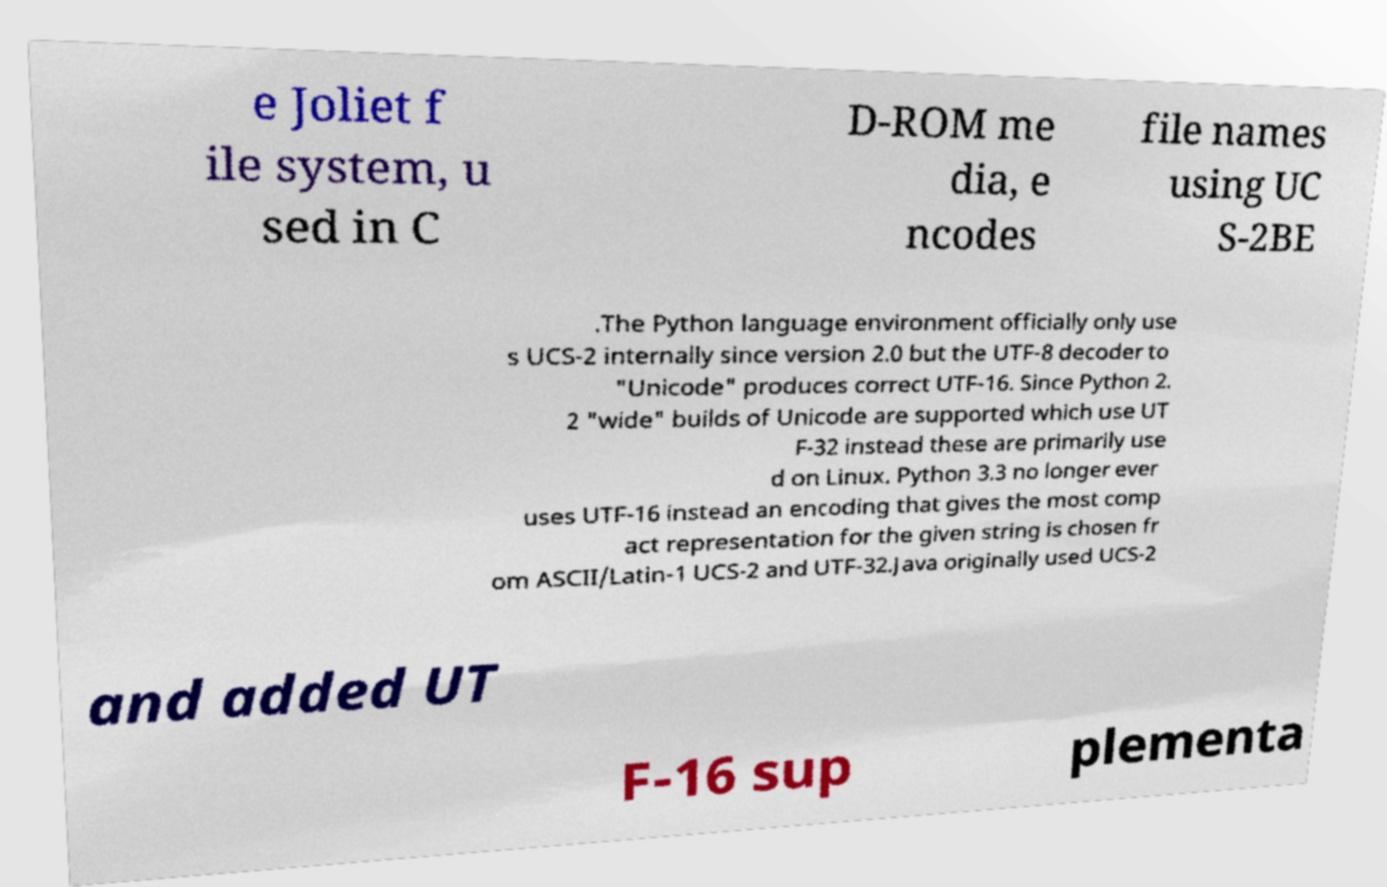Can you accurately transcribe the text from the provided image for me? e Joliet f ile system, u sed in C D-ROM me dia, e ncodes file names using UC S-2BE .The Python language environment officially only use s UCS-2 internally since version 2.0 but the UTF-8 decoder to "Unicode" produces correct UTF-16. Since Python 2. 2 "wide" builds of Unicode are supported which use UT F-32 instead these are primarily use d on Linux. Python 3.3 no longer ever uses UTF-16 instead an encoding that gives the most comp act representation for the given string is chosen fr om ASCII/Latin-1 UCS-2 and UTF-32.Java originally used UCS-2 and added UT F-16 sup plementa 